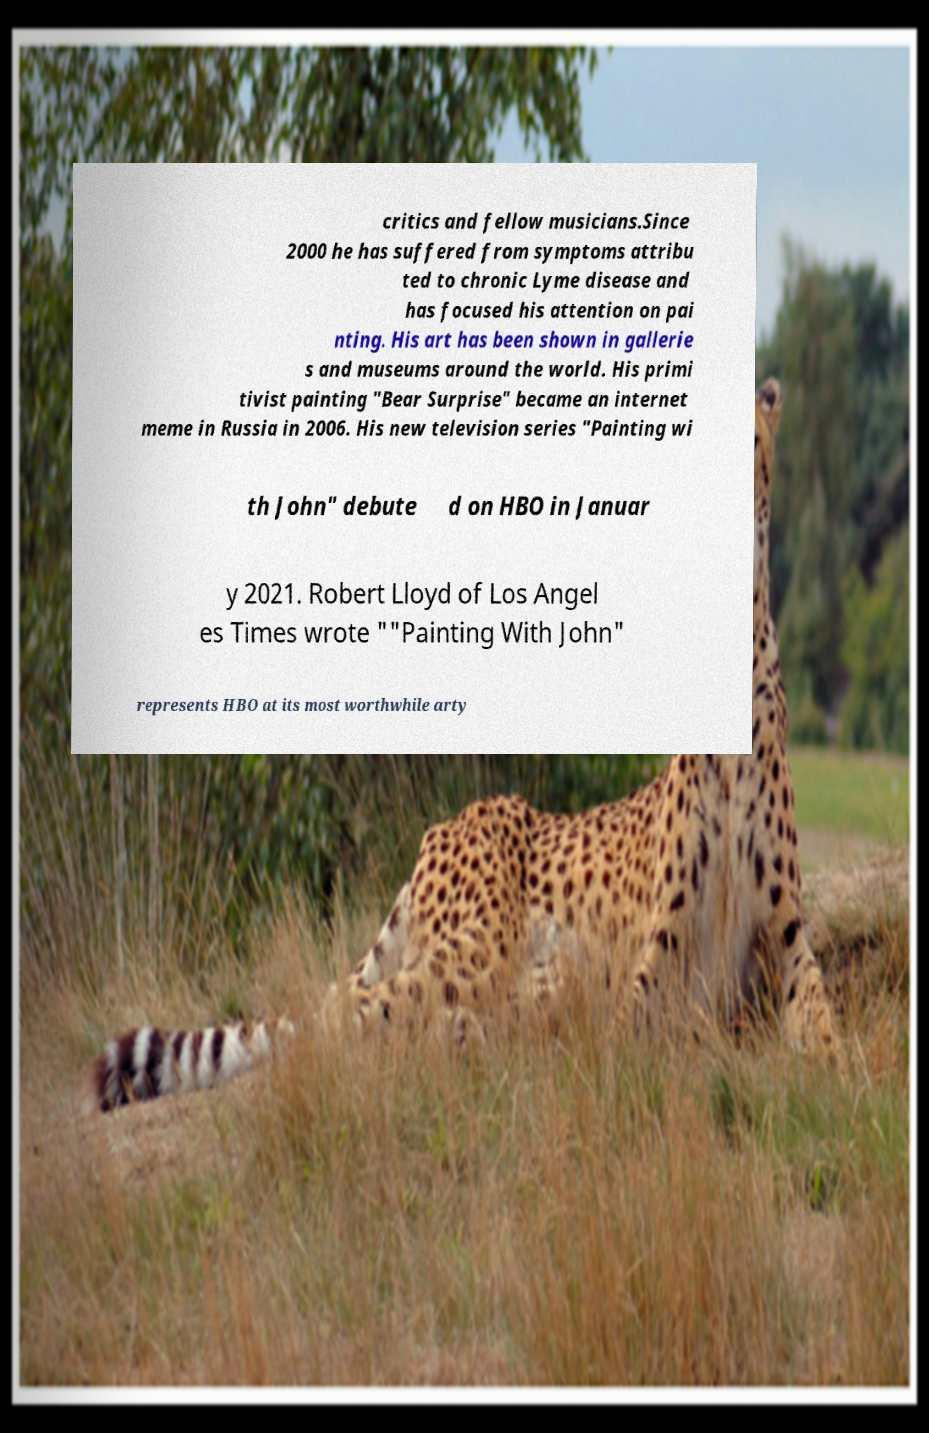For documentation purposes, I need the text within this image transcribed. Could you provide that? critics and fellow musicians.Since 2000 he has suffered from symptoms attribu ted to chronic Lyme disease and has focused his attention on pai nting. His art has been shown in gallerie s and museums around the world. His primi tivist painting "Bear Surprise" became an internet meme in Russia in 2006. His new television series "Painting wi th John" debute d on HBO in Januar y 2021. Robert Lloyd of Los Angel es Times wrote ""Painting With John" represents HBO at its most worthwhile arty 